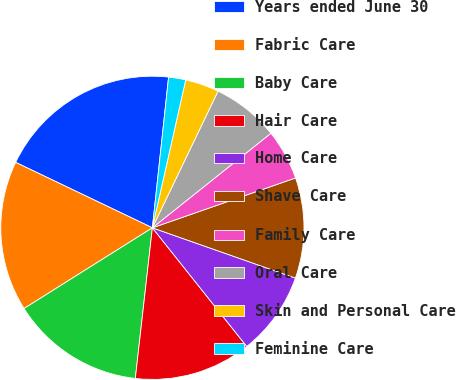Convert chart to OTSL. <chart><loc_0><loc_0><loc_500><loc_500><pie_chart><fcel>Years ended June 30<fcel>Fabric Care<fcel>Baby Care<fcel>Hair Care<fcel>Home Care<fcel>Shave Care<fcel>Family Care<fcel>Oral Care<fcel>Skin and Personal Care<fcel>Feminine Care<nl><fcel>19.6%<fcel>16.04%<fcel>14.27%<fcel>12.49%<fcel>8.93%<fcel>10.71%<fcel>5.38%<fcel>7.16%<fcel>3.6%<fcel>1.82%<nl></chart> 